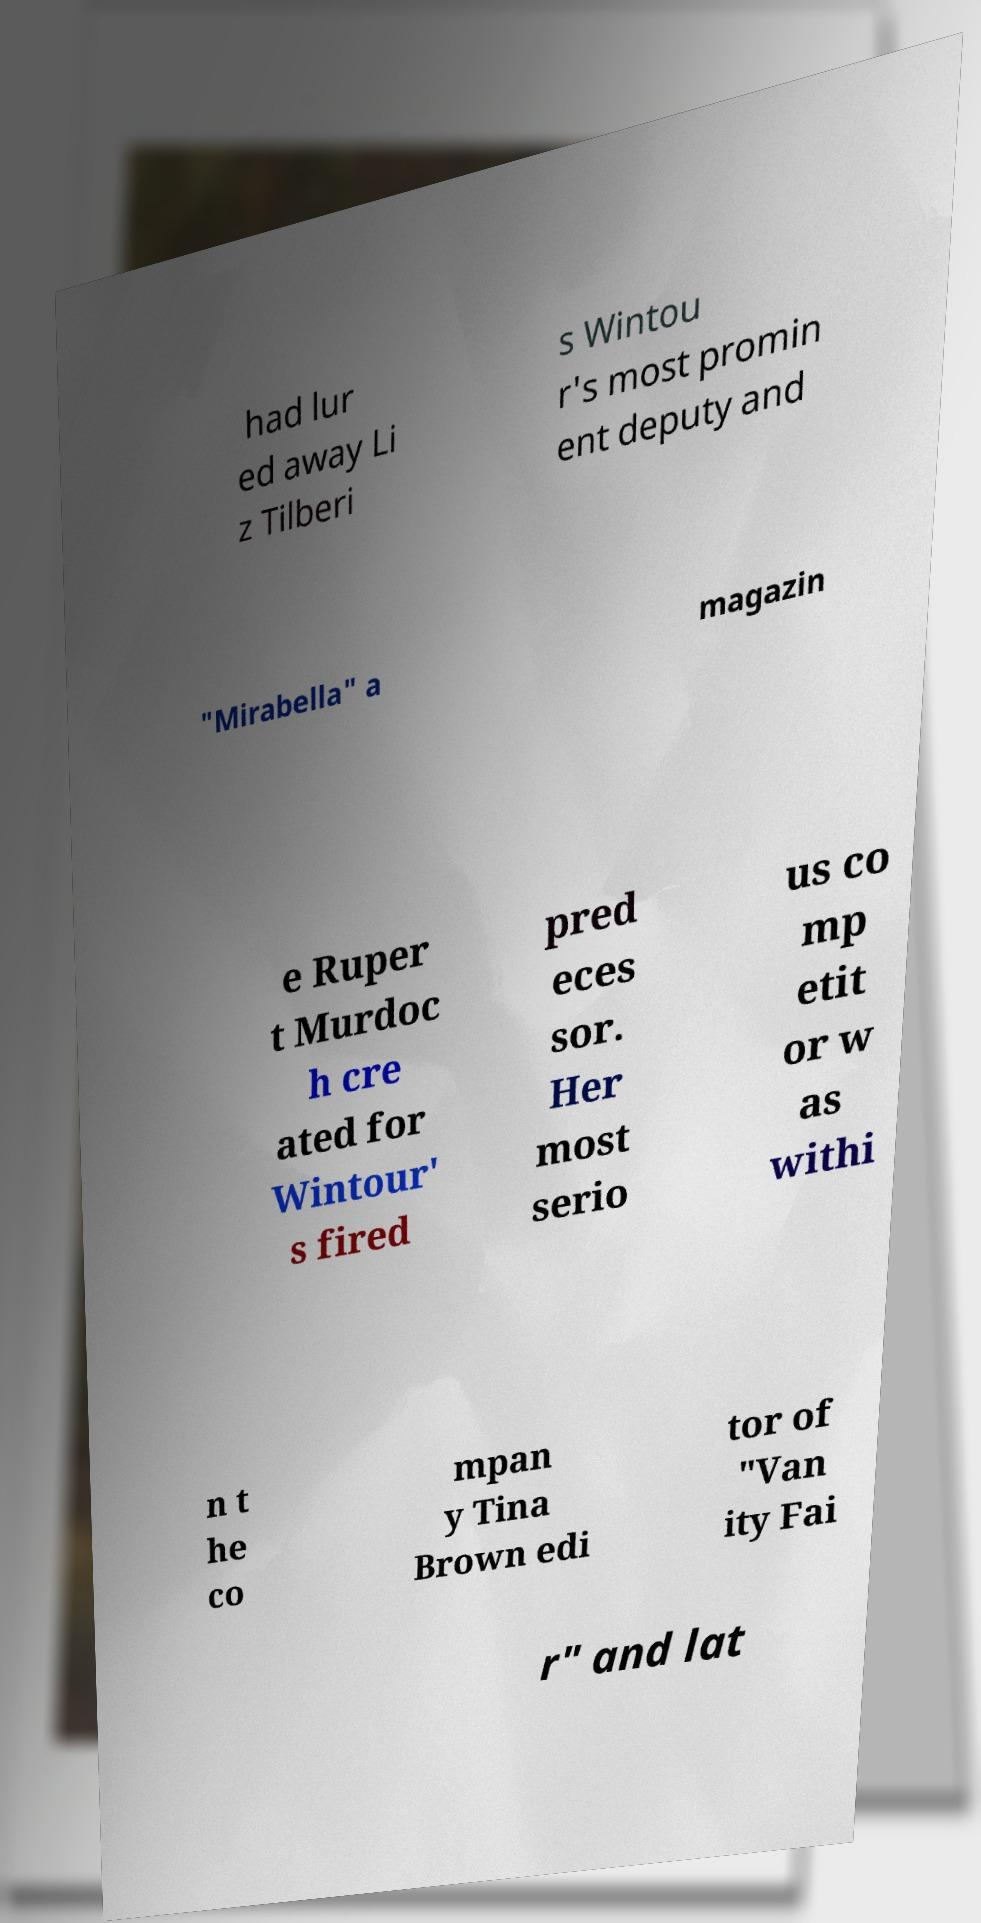Please read and relay the text visible in this image. What does it say? had lur ed away Li z Tilberi s Wintou r's most promin ent deputy and "Mirabella" a magazin e Ruper t Murdoc h cre ated for Wintour' s fired pred eces sor. Her most serio us co mp etit or w as withi n t he co mpan y Tina Brown edi tor of "Van ity Fai r" and lat 